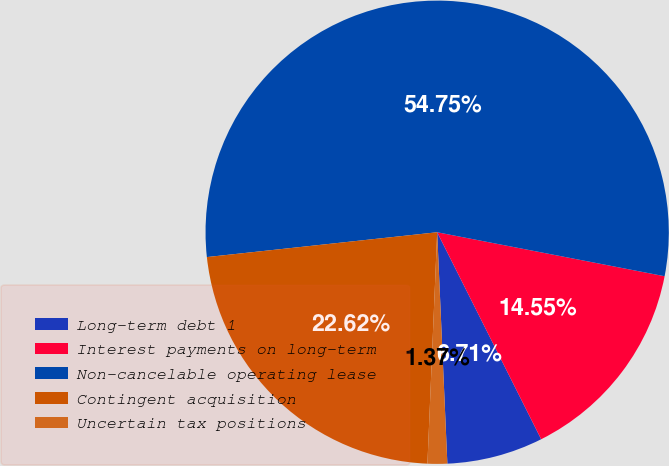Convert chart to OTSL. <chart><loc_0><loc_0><loc_500><loc_500><pie_chart><fcel>Long-term debt 1<fcel>Interest payments on long-term<fcel>Non-cancelable operating lease<fcel>Contingent acquisition<fcel>Uncertain tax positions<nl><fcel>6.71%<fcel>14.55%<fcel>54.75%<fcel>22.62%<fcel>1.37%<nl></chart> 